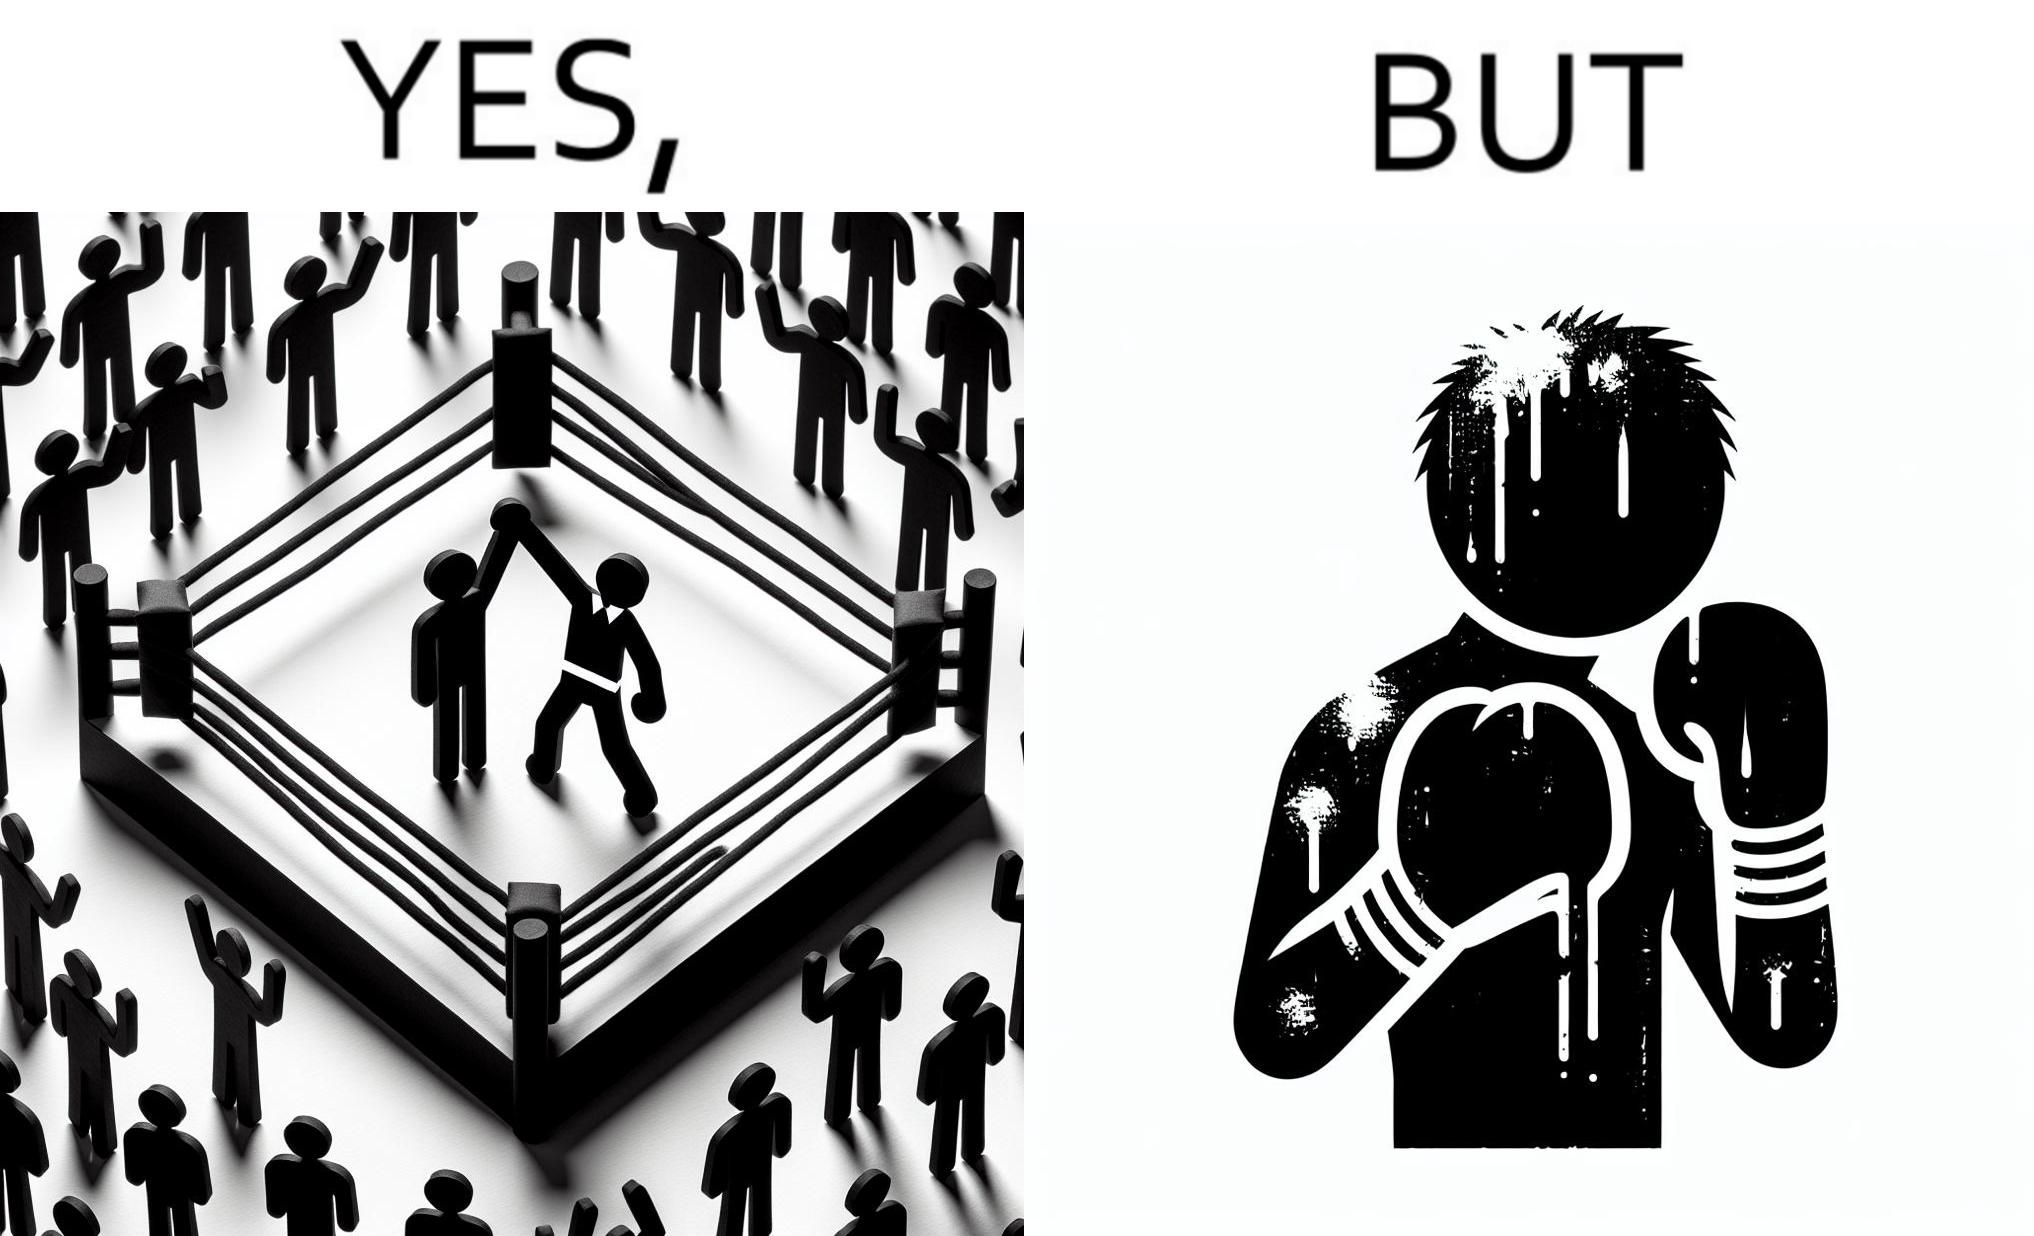Describe what you see in the left and right parts of this image. In the left part of the image: a referee announcing the winner of a boxing match. In the right part of the image: a bruised boxer. 